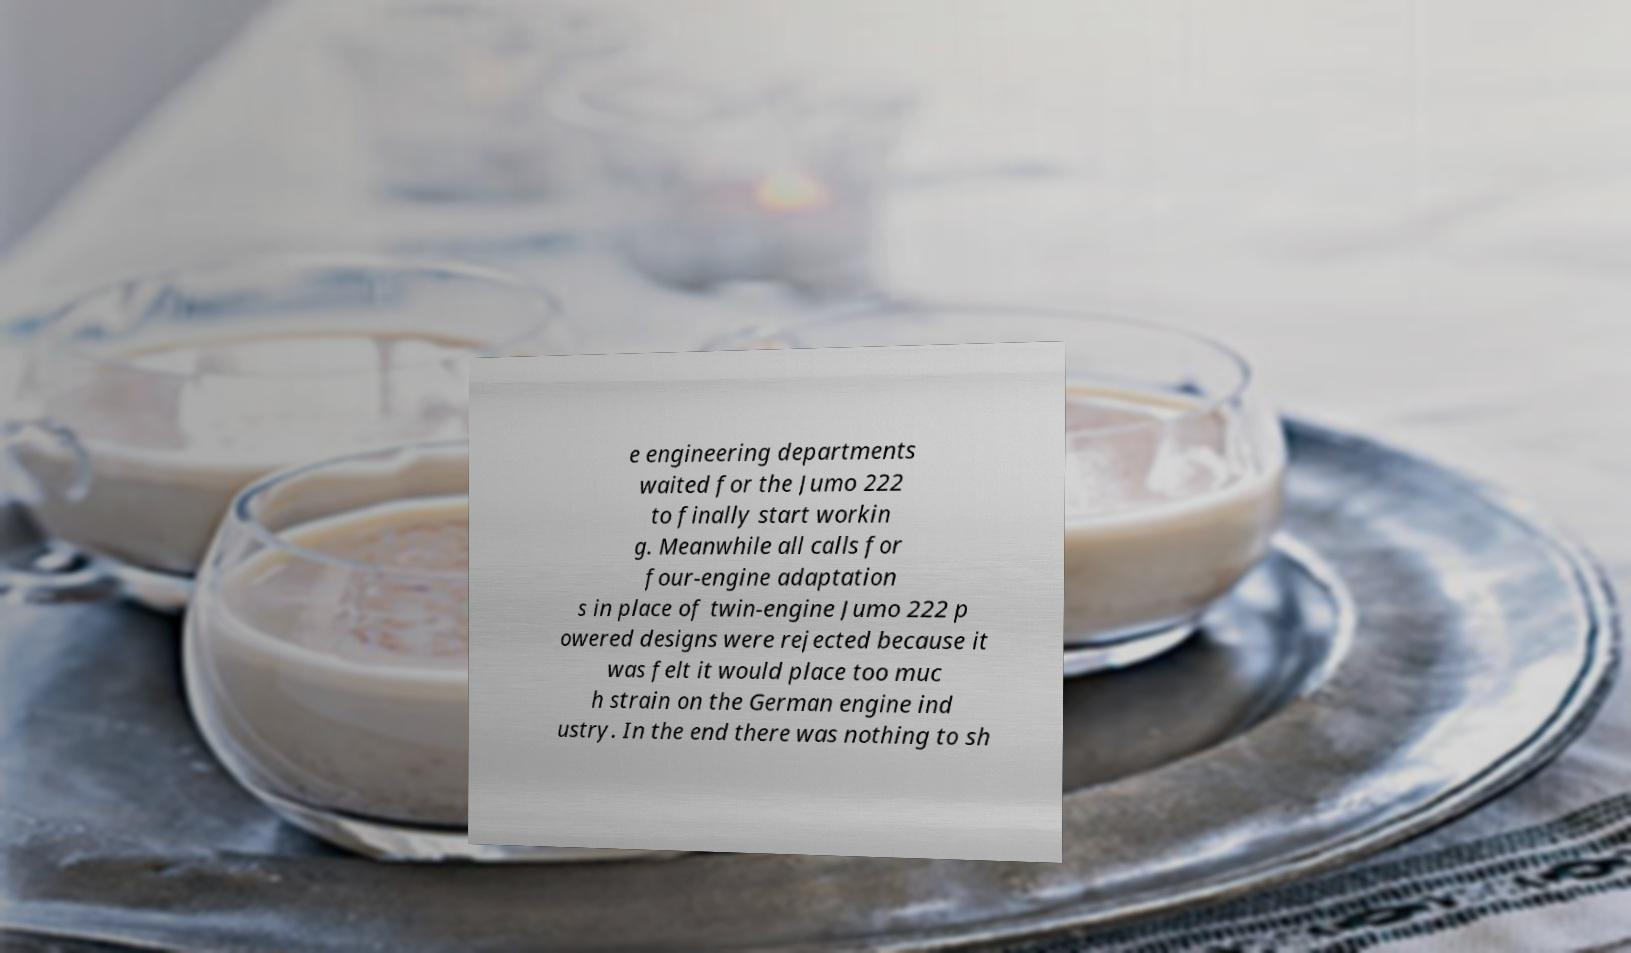Please identify and transcribe the text found in this image. e engineering departments waited for the Jumo 222 to finally start workin g. Meanwhile all calls for four-engine adaptation s in place of twin-engine Jumo 222 p owered designs were rejected because it was felt it would place too muc h strain on the German engine ind ustry. In the end there was nothing to sh 